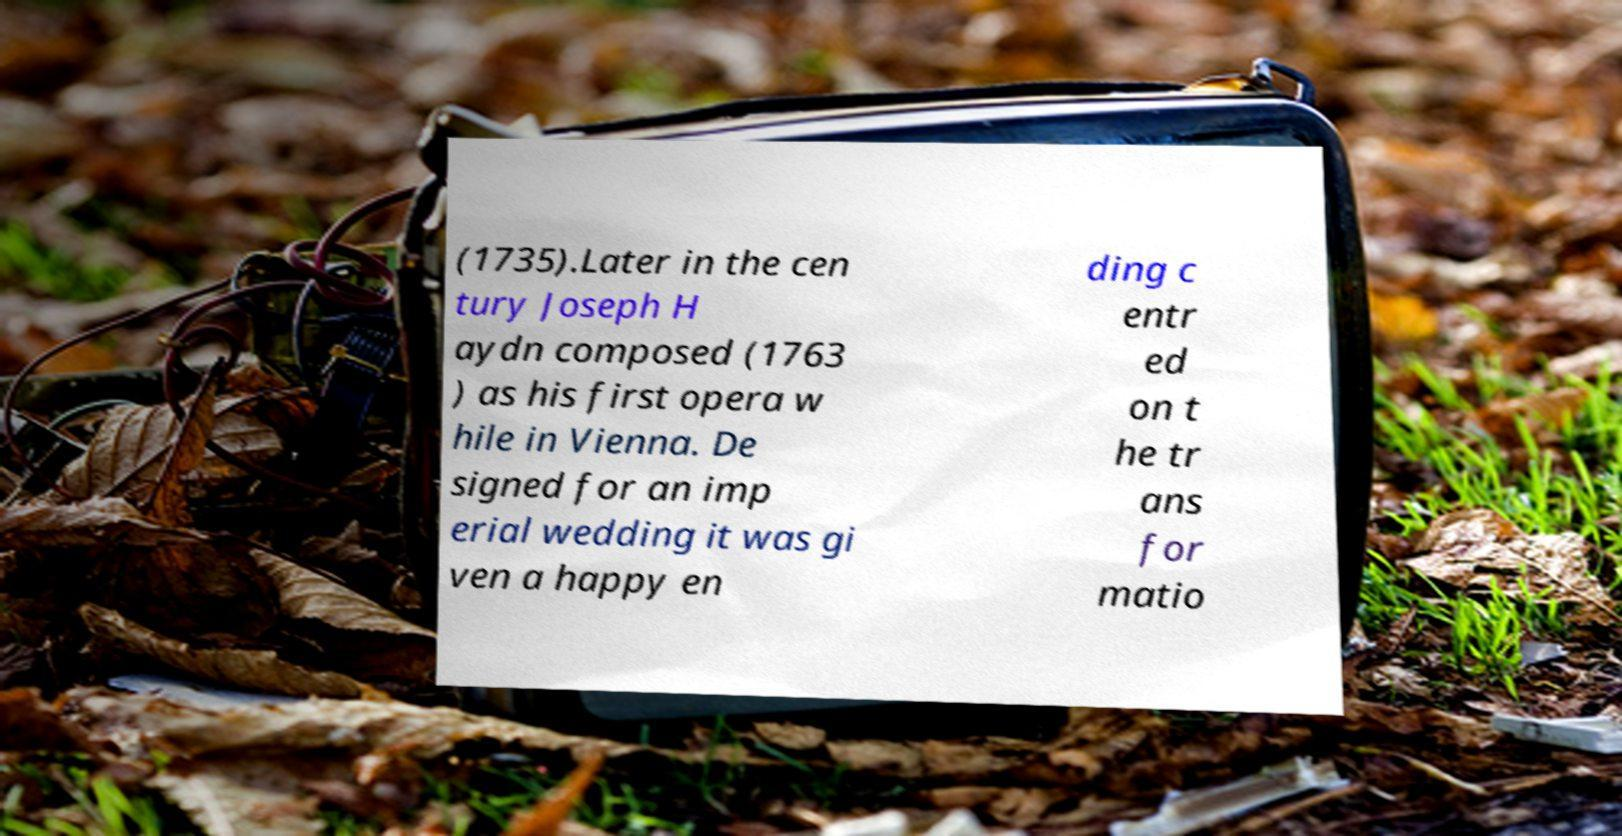Please read and relay the text visible in this image. What does it say? (1735).Later in the cen tury Joseph H aydn composed (1763 ) as his first opera w hile in Vienna. De signed for an imp erial wedding it was gi ven a happy en ding c entr ed on t he tr ans for matio 